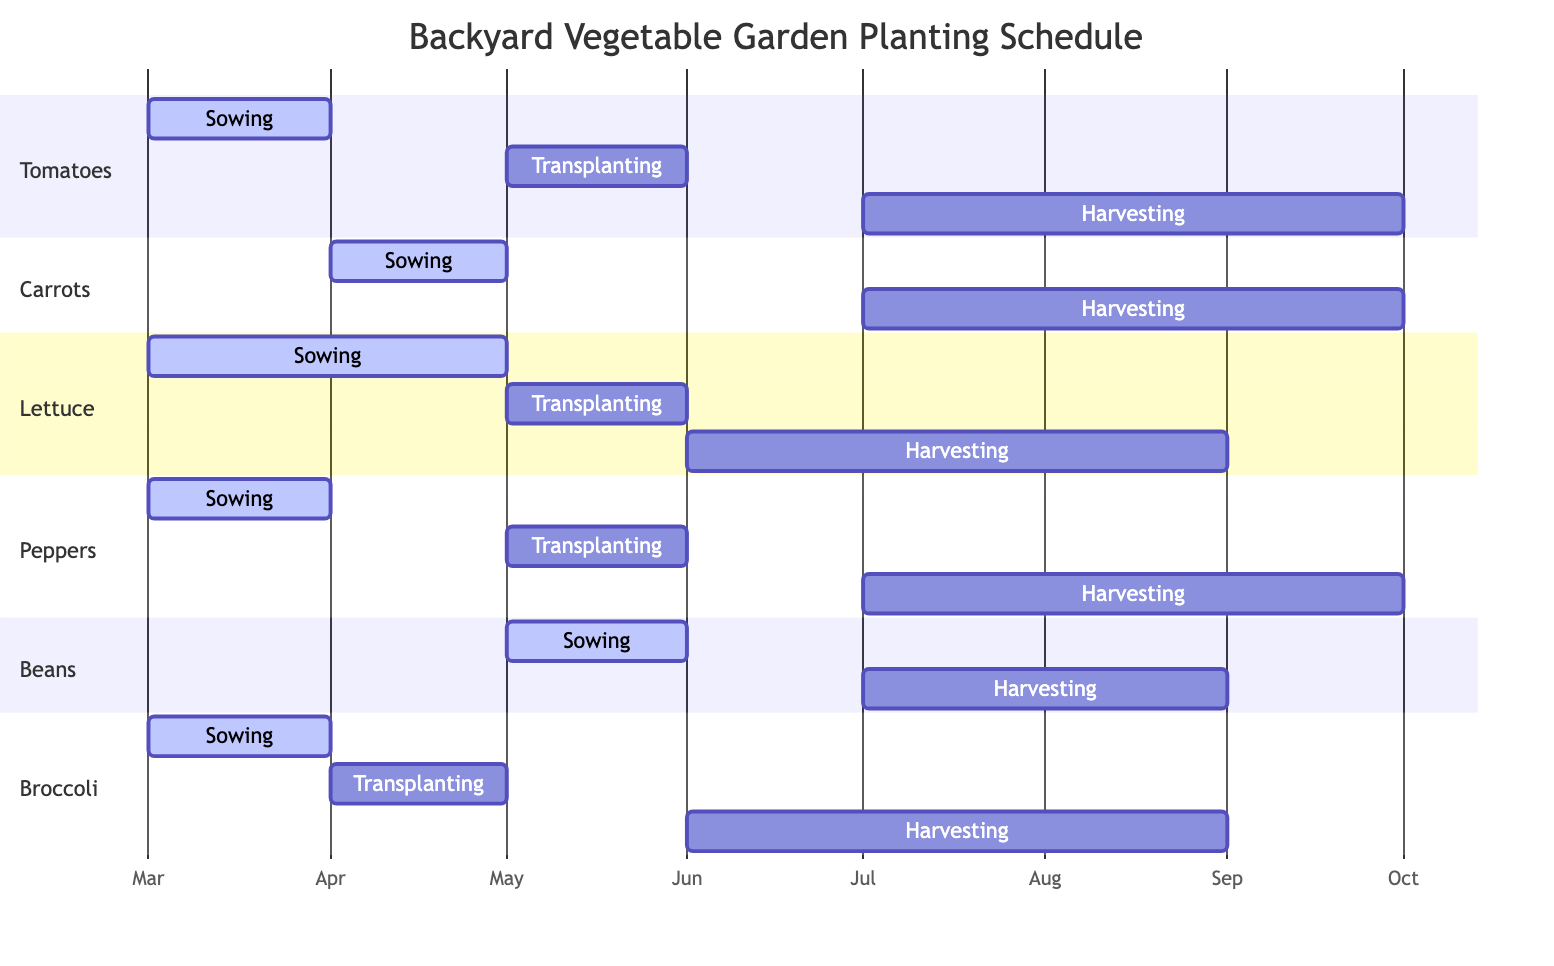What is the sowing month for tomatoes? The diagram shows that tomatoes are sown in March, as indicated by their sowing period.
Answer: March How long does the harvesting period for broccoli last? The harvesting period for broccoli starts on June 1 and lasts for 92 days, ending around August 31. Thus, it lasts for approximately three months.
Answer: 92 days Which vegetable is harvested from July to September? By examining the data, tomatoes, peppers, and carrots all have harvesting periods that span July to September. Thus, any of these quantities can be identified.
Answer: Tomatoes, Peppers How many different vegetables have a transplanting period? The diagram shows that tomatoes, lettuce, peppers, and broccoli have a transplanting period. Therefore, there are four vegetables that require transplanting.
Answer: Four What is the earliest sowing period among all vegetables? By reviewing the sowing periods, tomatoes, lettuce, and broccoli have a sowing period that starts in March, which is the earliest compared to the other vegetables.
Answer: March Which vegetable's sowing period is in April? Carrots are the only vegetable whose sowing period starts in April, as indicated in the diagram.
Answer: Carrots 